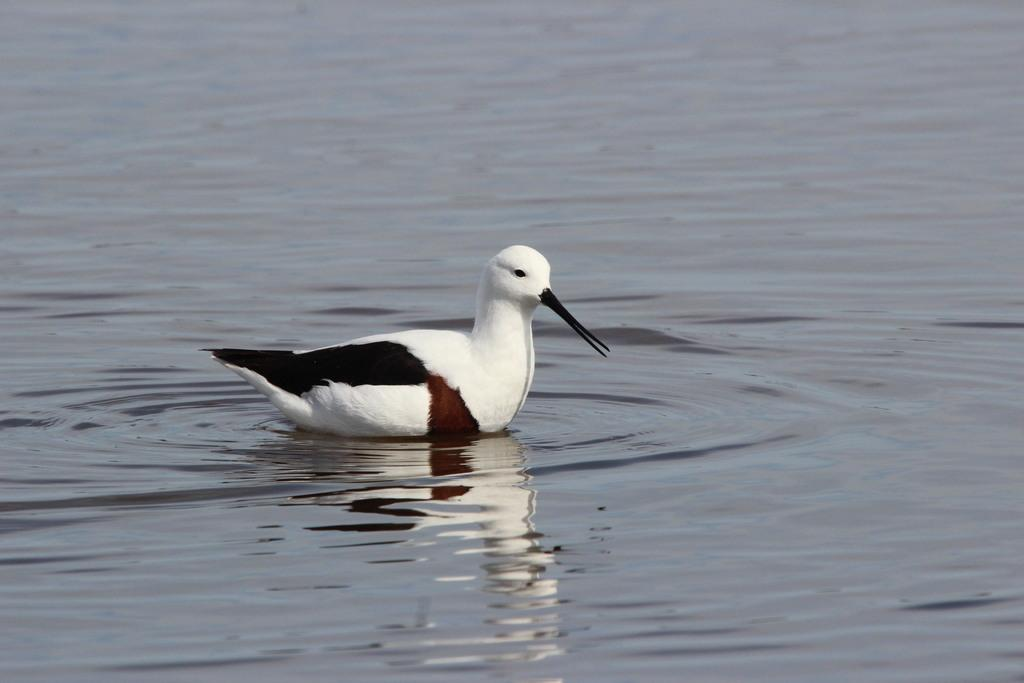What type of animal is in the image? There is a water bird in the image. Can you describe the color pattern of the bird? The bird is black, brown, and white in color. What type of sack is the bird carrying on its face in the image? There is no sack present in the image, nor is the bird carrying anything on its face. 